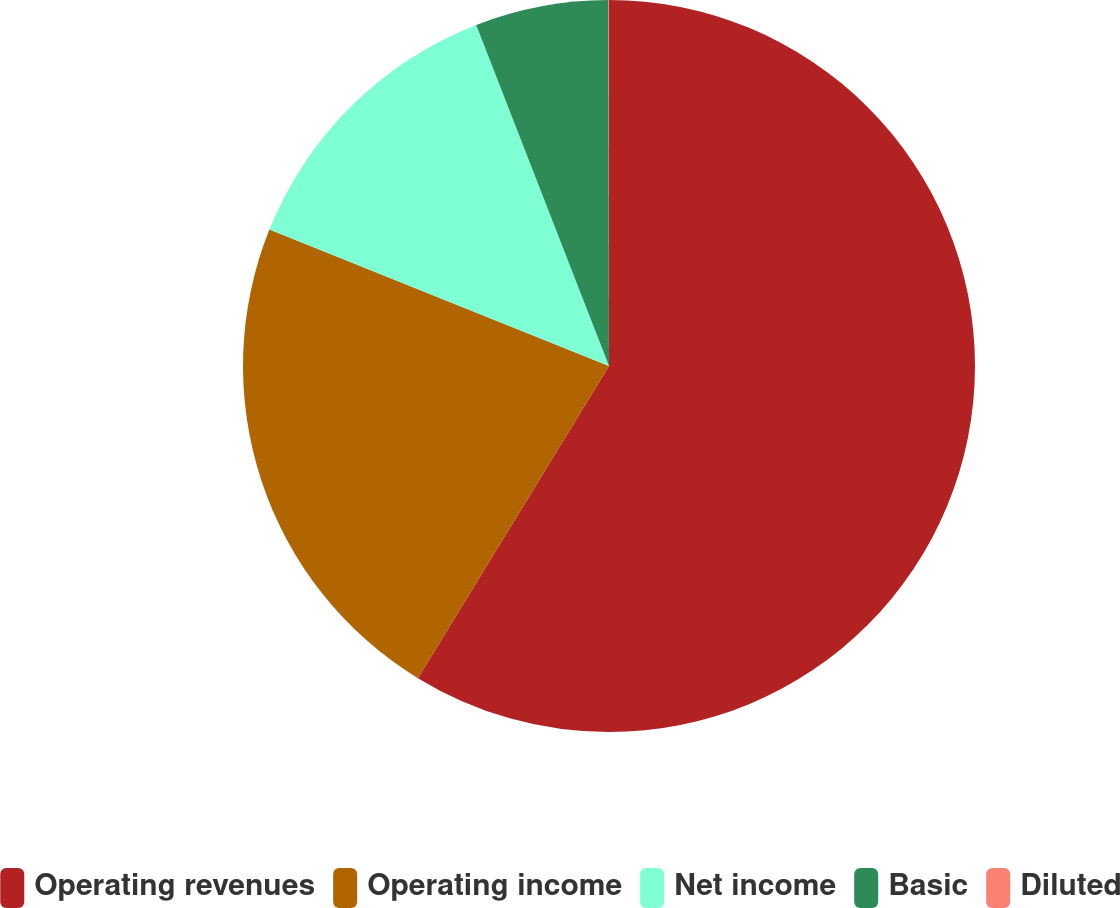Convert chart. <chart><loc_0><loc_0><loc_500><loc_500><pie_chart><fcel>Operating revenues<fcel>Operating income<fcel>Net income<fcel>Basic<fcel>Diluted<nl><fcel>58.75%<fcel>22.34%<fcel>13.01%<fcel>5.89%<fcel>0.02%<nl></chart> 